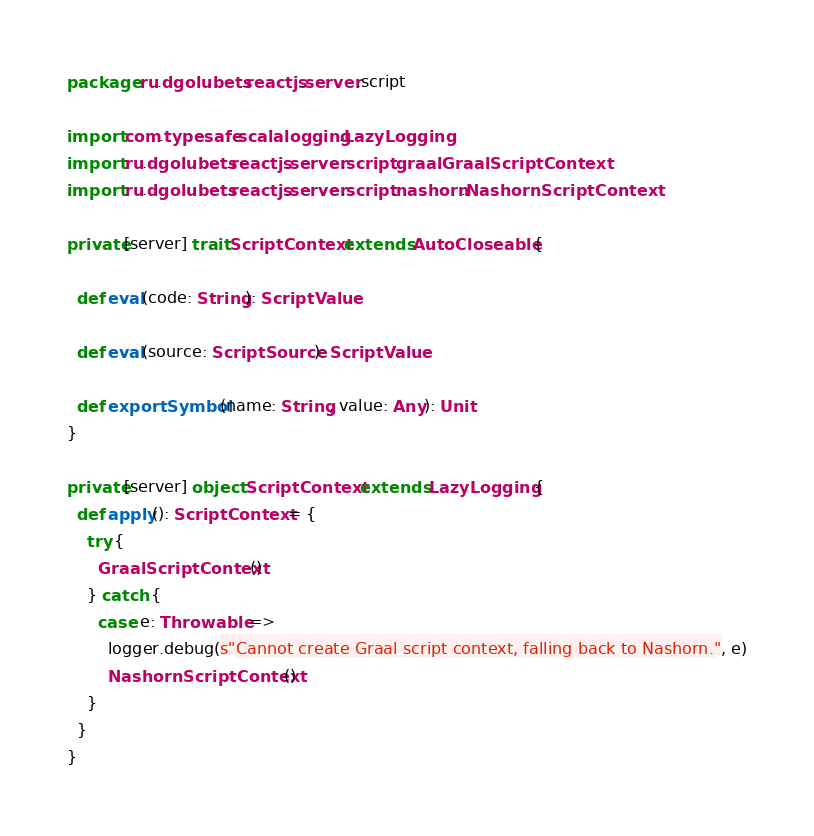<code> <loc_0><loc_0><loc_500><loc_500><_Scala_>package ru.dgolubets.reactjs.server.script

import com.typesafe.scalalogging.LazyLogging
import ru.dgolubets.reactjs.server.script.graal.GraalScriptContext
import ru.dgolubets.reactjs.server.script.nashorn.NashornScriptContext

private[server] trait ScriptContext extends AutoCloseable {

  def eval(code: String): ScriptValue

  def eval(source: ScriptSource): ScriptValue

  def exportSymbol(name: String, value: Any): Unit
}

private[server] object ScriptContext extends LazyLogging {
  def apply(): ScriptContext = {
    try {
      GraalScriptContext()
    } catch {
      case e: Throwable =>
        logger.debug(s"Cannot create Graal script context, falling back to Nashorn.", e)
        NashornScriptContext()
    }
  }
}

</code> 